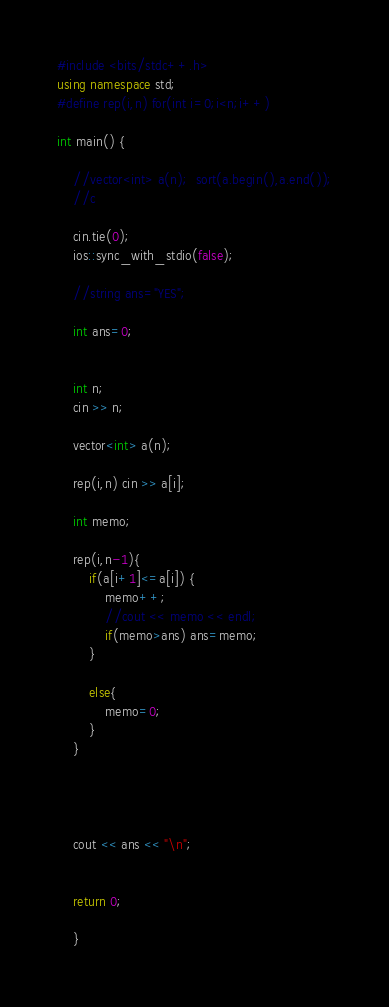Convert code to text. <code><loc_0><loc_0><loc_500><loc_500><_C++_>#include <bits/stdc++.h>
using namespace std;
#define rep(i,n) for(int i=0;i<n;i++)

int main() {
	
	//vector<int> a(n);  sort(a.begin(),a.end());
	//c

	cin.tie(0);
	ios::sync_with_stdio(false);
	
	//string ans="YES";
	
	int ans=0;


	int n;
	cin >> n;
	
	vector<int> a(n);
	
	rep(i,n) cin >> a[i];
	
	int memo;
	
	rep(i,n-1){
		if(a[i+1]<=a[i]) {
			memo++;
			//cout << memo << endl;
			if(memo>ans) ans=memo;
		}
		
		else{
			memo=0;
		}
	}
	
	
	
	
	cout << ans << "\n";
	
	
	return 0;

    }</code> 